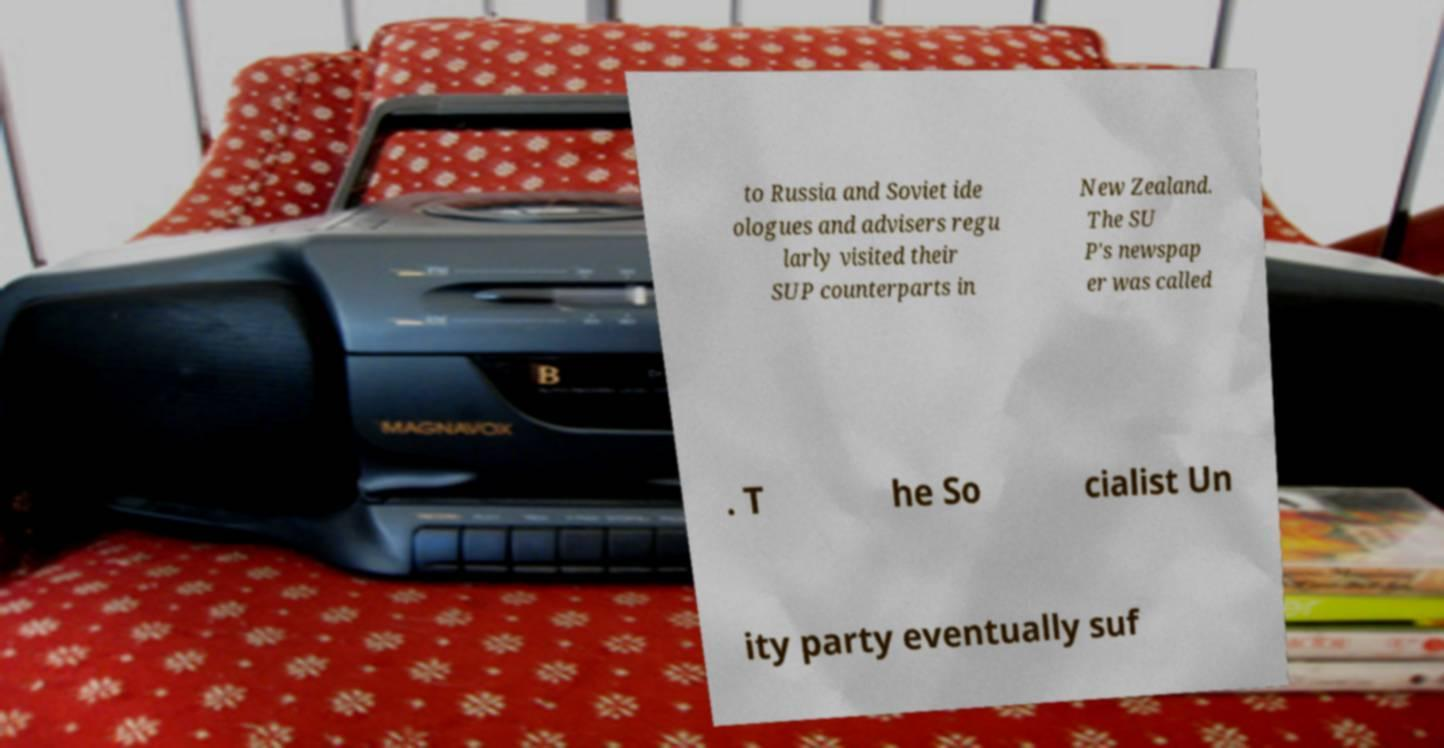Could you extract and type out the text from this image? to Russia and Soviet ide ologues and advisers regu larly visited their SUP counterparts in New Zealand. The SU P's newspap er was called . T he So cialist Un ity party eventually suf 